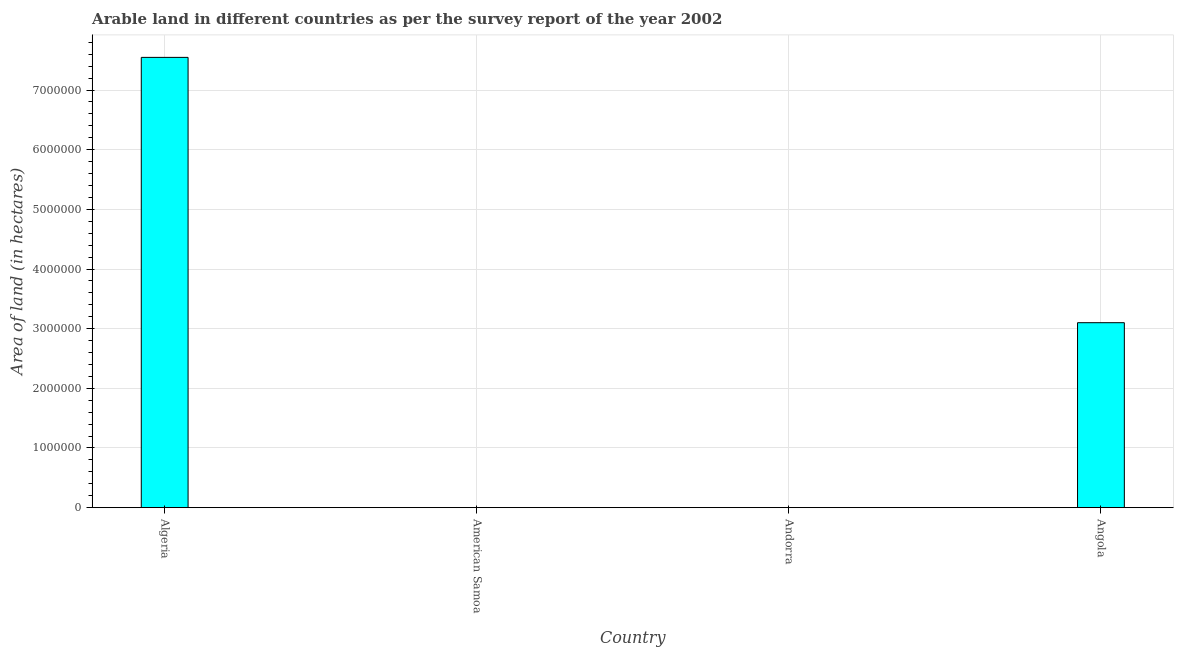What is the title of the graph?
Provide a succinct answer. Arable land in different countries as per the survey report of the year 2002. What is the label or title of the X-axis?
Your response must be concise. Country. What is the label or title of the Y-axis?
Provide a succinct answer. Area of land (in hectares). What is the area of land in Algeria?
Offer a very short reply. 7.55e+06. Across all countries, what is the maximum area of land?
Provide a succinct answer. 7.55e+06. Across all countries, what is the minimum area of land?
Ensure brevity in your answer.  2500. In which country was the area of land maximum?
Provide a short and direct response. Algeria. In which country was the area of land minimum?
Your answer should be very brief. American Samoa. What is the sum of the area of land?
Your response must be concise. 1.07e+07. What is the difference between the area of land in Andorra and Angola?
Offer a very short reply. -3.10e+06. What is the average area of land per country?
Provide a short and direct response. 2.66e+06. What is the median area of land?
Your response must be concise. 1.55e+06. In how many countries, is the area of land greater than 6000000 hectares?
Your answer should be very brief. 1. What is the ratio of the area of land in Algeria to that in American Samoa?
Your response must be concise. 3018.8. Is the difference between the area of land in Algeria and American Samoa greater than the difference between any two countries?
Give a very brief answer. Yes. What is the difference between the highest and the second highest area of land?
Give a very brief answer. 4.45e+06. What is the difference between the highest and the lowest area of land?
Offer a very short reply. 7.54e+06. In how many countries, is the area of land greater than the average area of land taken over all countries?
Provide a succinct answer. 2. How many countries are there in the graph?
Your response must be concise. 4. What is the difference between two consecutive major ticks on the Y-axis?
Provide a succinct answer. 1.00e+06. Are the values on the major ticks of Y-axis written in scientific E-notation?
Your answer should be compact. No. What is the Area of land (in hectares) in Algeria?
Ensure brevity in your answer.  7.55e+06. What is the Area of land (in hectares) of American Samoa?
Offer a terse response. 2500. What is the Area of land (in hectares) of Andorra?
Offer a terse response. 2500. What is the Area of land (in hectares) in Angola?
Provide a short and direct response. 3.10e+06. What is the difference between the Area of land (in hectares) in Algeria and American Samoa?
Offer a terse response. 7.54e+06. What is the difference between the Area of land (in hectares) in Algeria and Andorra?
Ensure brevity in your answer.  7.54e+06. What is the difference between the Area of land (in hectares) in Algeria and Angola?
Provide a succinct answer. 4.45e+06. What is the difference between the Area of land (in hectares) in American Samoa and Angola?
Offer a terse response. -3.10e+06. What is the difference between the Area of land (in hectares) in Andorra and Angola?
Provide a succinct answer. -3.10e+06. What is the ratio of the Area of land (in hectares) in Algeria to that in American Samoa?
Offer a terse response. 3018.8. What is the ratio of the Area of land (in hectares) in Algeria to that in Andorra?
Provide a short and direct response. 3018.8. What is the ratio of the Area of land (in hectares) in Algeria to that in Angola?
Your answer should be compact. 2.44. What is the ratio of the Area of land (in hectares) in American Samoa to that in Andorra?
Provide a succinct answer. 1. 